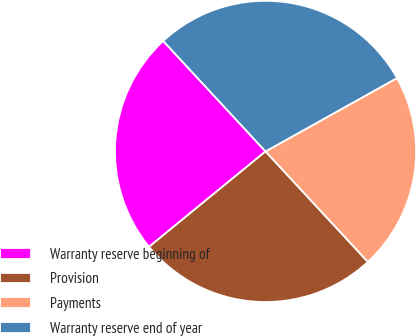Convert chart to OTSL. <chart><loc_0><loc_0><loc_500><loc_500><pie_chart><fcel>Warranty reserve beginning of<fcel>Provision<fcel>Payments<fcel>Warranty reserve end of year<nl><fcel>24.03%<fcel>25.97%<fcel>21.21%<fcel>28.79%<nl></chart> 